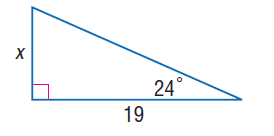Question: Find x.
Choices:
A. 1.5
B. 2.0
C. 8.0
D. 8.5
Answer with the letter. Answer: D 